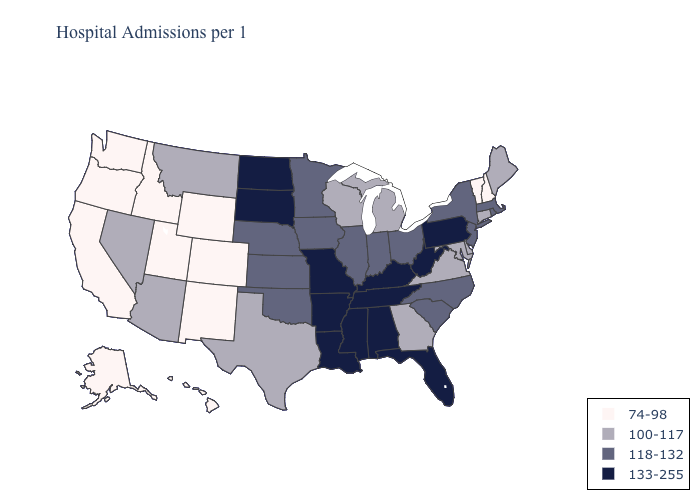Among the states that border Virginia , does North Carolina have the highest value?
Answer briefly. No. Name the states that have a value in the range 133-255?
Quick response, please. Alabama, Arkansas, Florida, Kentucky, Louisiana, Mississippi, Missouri, North Dakota, Pennsylvania, South Dakota, Tennessee, West Virginia. Name the states that have a value in the range 118-132?
Short answer required. Illinois, Indiana, Iowa, Kansas, Massachusetts, Minnesota, Nebraska, New Jersey, New York, North Carolina, Ohio, Oklahoma, Rhode Island, South Carolina. Does North Carolina have the highest value in the South?
Concise answer only. No. Does the map have missing data?
Concise answer only. No. What is the value of Virginia?
Concise answer only. 100-117. What is the value of West Virginia?
Give a very brief answer. 133-255. Does Wisconsin have the lowest value in the USA?
Short answer required. No. Among the states that border Pennsylvania , does New York have the lowest value?
Quick response, please. No. Which states have the highest value in the USA?
Concise answer only. Alabama, Arkansas, Florida, Kentucky, Louisiana, Mississippi, Missouri, North Dakota, Pennsylvania, South Dakota, Tennessee, West Virginia. What is the value of New Hampshire?
Be succinct. 74-98. Name the states that have a value in the range 118-132?
Give a very brief answer. Illinois, Indiana, Iowa, Kansas, Massachusetts, Minnesota, Nebraska, New Jersey, New York, North Carolina, Ohio, Oklahoma, Rhode Island, South Carolina. Does North Carolina have the same value as Oregon?
Keep it brief. No. Does Minnesota have the lowest value in the USA?
Write a very short answer. No. Which states have the lowest value in the USA?
Quick response, please. Alaska, California, Colorado, Hawaii, Idaho, New Hampshire, New Mexico, Oregon, Utah, Vermont, Washington, Wyoming. 